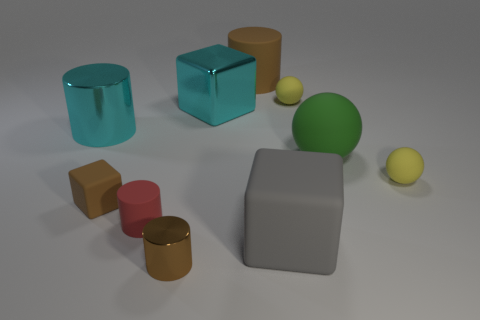There is a cyan object that is to the right of the brown cylinder that is in front of the cyan shiny cube; what is its material?
Provide a succinct answer. Metal. There is a cyan shiny thing that is the same shape as the small red rubber object; what is its size?
Give a very brief answer. Large. There is a large shiny thing left of the small brown rubber thing; does it have the same color as the large metal block?
Your answer should be compact. Yes. Is the number of big cyan blocks less than the number of gray metal cubes?
Your answer should be compact. No. What number of other objects are the same color as the large sphere?
Keep it short and to the point. 0. Are the large cyan thing right of the cyan metal cylinder and the small brown cylinder made of the same material?
Your response must be concise. Yes. What is the material of the tiny cylinder behind the gray cube?
Give a very brief answer. Rubber. There is a brown cylinder behind the shiny cylinder in front of the gray thing; what is its size?
Your response must be concise. Large. Is there a gray cube made of the same material as the large brown cylinder?
Ensure brevity in your answer.  Yes. The large thing behind the small yellow rubber object to the left of the small matte sphere that is right of the big green ball is what shape?
Offer a very short reply. Cylinder. 